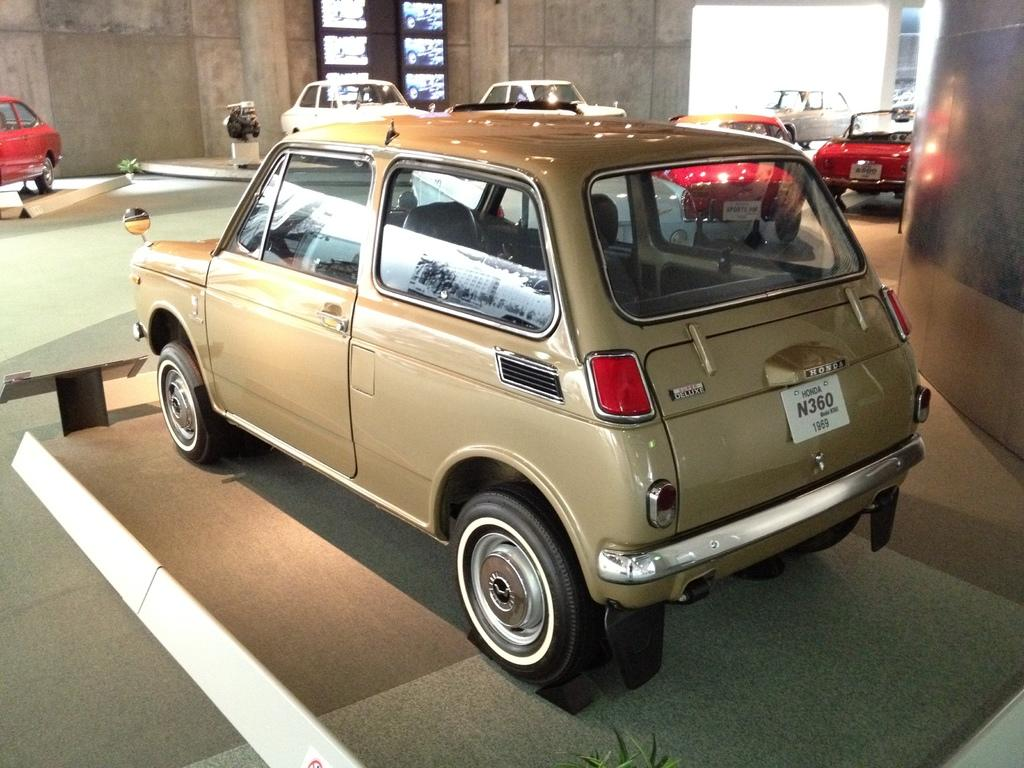What is the main subject of the image? The main subject of the image is a group of cars. How are the cars positioned in the image? The cars are placed on a surface in the image. What other objects or elements can be seen in the image? There are plants, a wall, and a window in the image. What type of flesh can be seen on the cars in the image? There is no flesh present on the cars in the image; they are vehicles made of metal and other materials. 